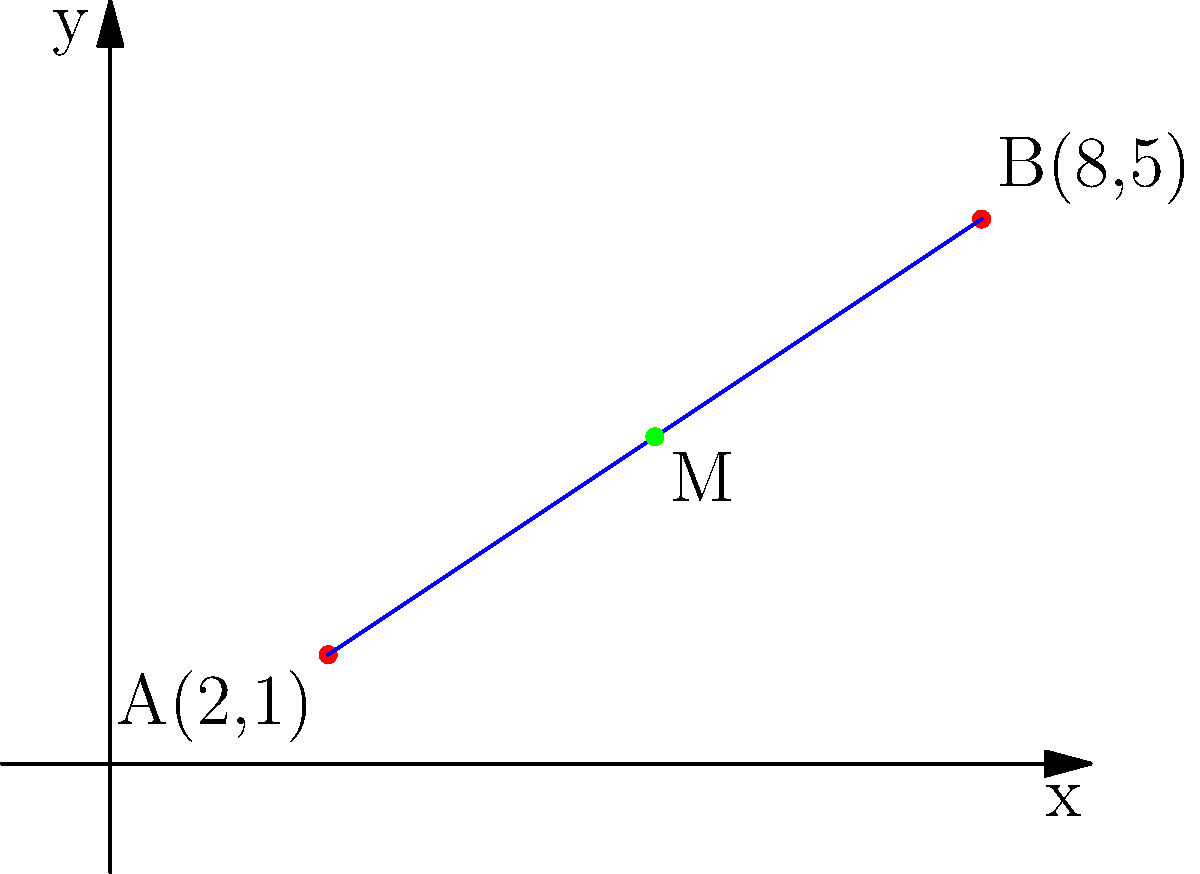In the coordinate plane above, points A(2,1) and B(8,5) are the endpoints of a line segment. Find the coordinates of the midpoint M of this line segment. To find the midpoint of a line segment, we can use the midpoint formula:

$$ M = (\frac{x_1 + x_2}{2}, \frac{y_1 + y_2}{2}) $$

Where $(x_1, y_1)$ are the coordinates of one endpoint and $(x_2, y_2)$ are the coordinates of the other endpoint.

Given:
- Point A: $(2, 1)$
- Point B: $(8, 5)$

Step 1: Calculate the x-coordinate of the midpoint:
$$ x_M = \frac{x_1 + x_2}{2} = \frac{2 + 8}{2} = \frac{10}{2} = 5 $$

Step 2: Calculate the y-coordinate of the midpoint:
$$ y_M = \frac{y_1 + y_2}{2} = \frac{1 + 5}{2} = \frac{6}{2} = 3 $$

Therefore, the coordinates of the midpoint M are (5, 3).
Answer: (5, 3) 